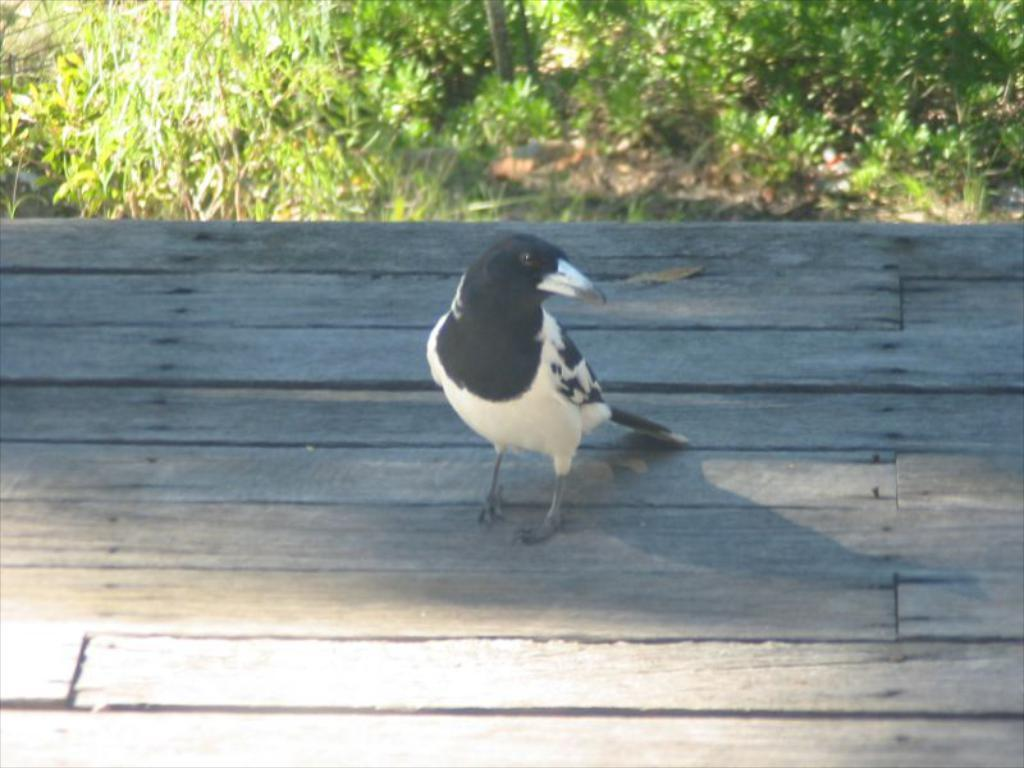What type of animal can be seen in the image? There is a bird in the image. Where is the bird located? The bird is on a wooden surface. What can be seen in the background of the image? There is a grassland in the background of the image. What type of sail can be seen on the bird in the image? There is no sail present on the bird in the image. Where is the recess located in the image? There is no recess present in the image. 